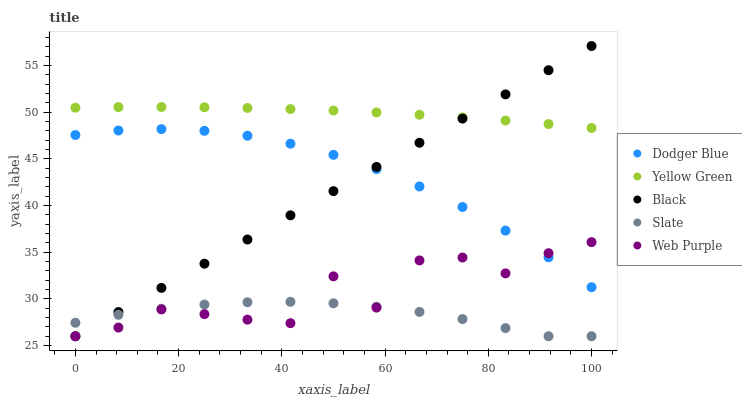Does Slate have the minimum area under the curve?
Answer yes or no. Yes. Does Yellow Green have the maximum area under the curve?
Answer yes or no. Yes. Does Dodger Blue have the minimum area under the curve?
Answer yes or no. No. Does Dodger Blue have the maximum area under the curve?
Answer yes or no. No. Is Black the smoothest?
Answer yes or no. Yes. Is Web Purple the roughest?
Answer yes or no. Yes. Is Slate the smoothest?
Answer yes or no. No. Is Slate the roughest?
Answer yes or no. No. Does Black have the lowest value?
Answer yes or no. Yes. Does Dodger Blue have the lowest value?
Answer yes or no. No. Does Black have the highest value?
Answer yes or no. Yes. Does Dodger Blue have the highest value?
Answer yes or no. No. Is Slate less than Dodger Blue?
Answer yes or no. Yes. Is Yellow Green greater than Dodger Blue?
Answer yes or no. Yes. Does Black intersect Dodger Blue?
Answer yes or no. Yes. Is Black less than Dodger Blue?
Answer yes or no. No. Is Black greater than Dodger Blue?
Answer yes or no. No. Does Slate intersect Dodger Blue?
Answer yes or no. No. 